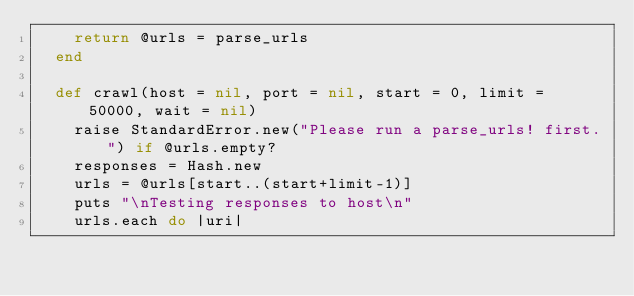<code> <loc_0><loc_0><loc_500><loc_500><_Ruby_>    return @urls = parse_urls
  end
  
  def crawl(host = nil, port = nil, start = 0, limit = 50000, wait = nil)
    raise StandardError.new("Please run a parse_urls! first.") if @urls.empty?
    responses = Hash.new
    urls = @urls[start..(start+limit-1)]
    puts "\nTesting responses to host\n"
    urls.each do |uri|</code> 